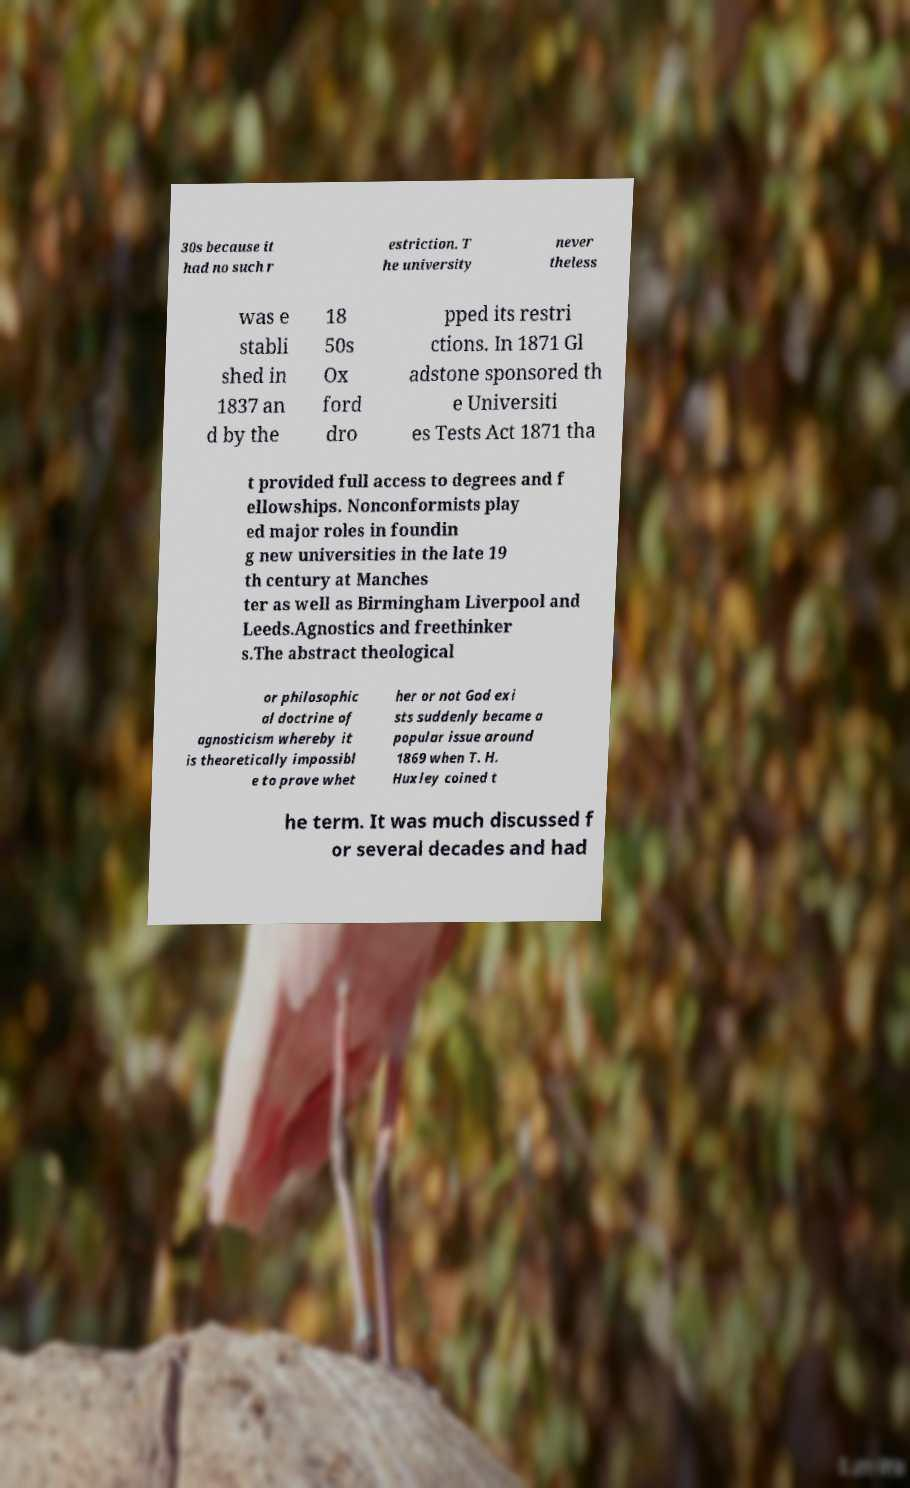Could you extract and type out the text from this image? 30s because it had no such r estriction. T he university never theless was e stabli shed in 1837 an d by the 18 50s Ox ford dro pped its restri ctions. In 1871 Gl adstone sponsored th e Universiti es Tests Act 1871 tha t provided full access to degrees and f ellowships. Nonconformists play ed major roles in foundin g new universities in the late 19 th century at Manches ter as well as Birmingham Liverpool and Leeds.Agnostics and freethinker s.The abstract theological or philosophic al doctrine of agnosticism whereby it is theoretically impossibl e to prove whet her or not God exi sts suddenly became a popular issue around 1869 when T. H. Huxley coined t he term. It was much discussed f or several decades and had 